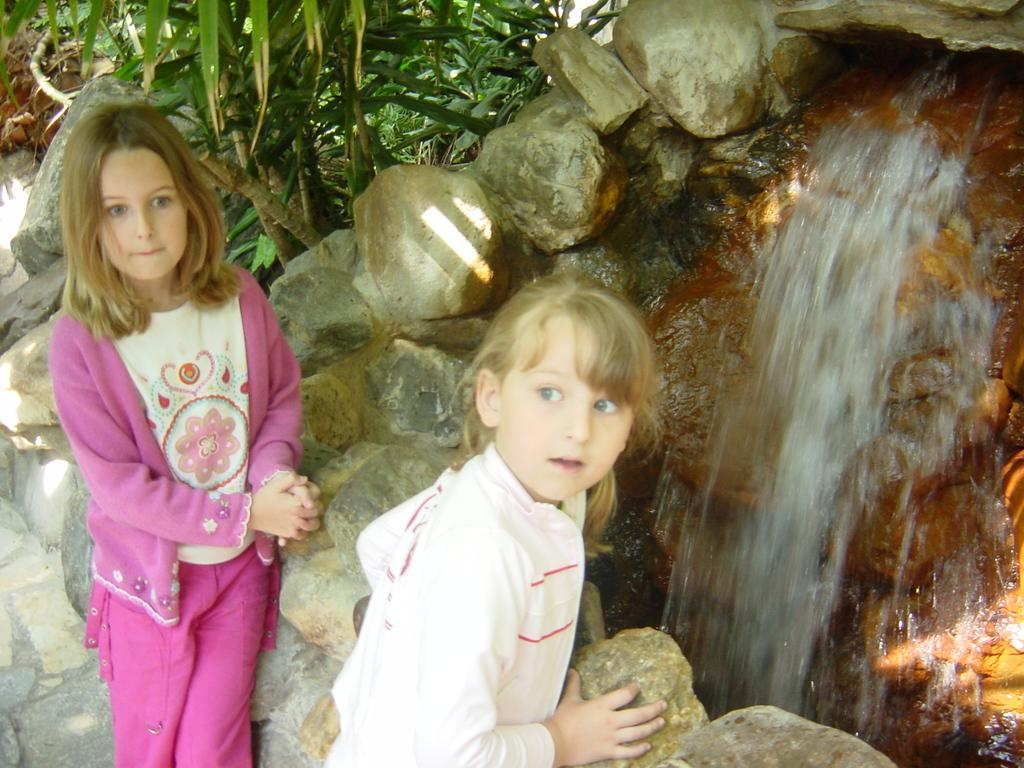How many kids are in the image? There are two kids in the image. What can be seen in the background of the image? There is a fountain and trees in the background of the image. What type of natural elements are present in the image? Rocks are present in the image. What type of paste is being used by the kids in the image? There is no paste visible in the image, and the kids are not shown using any paste. 